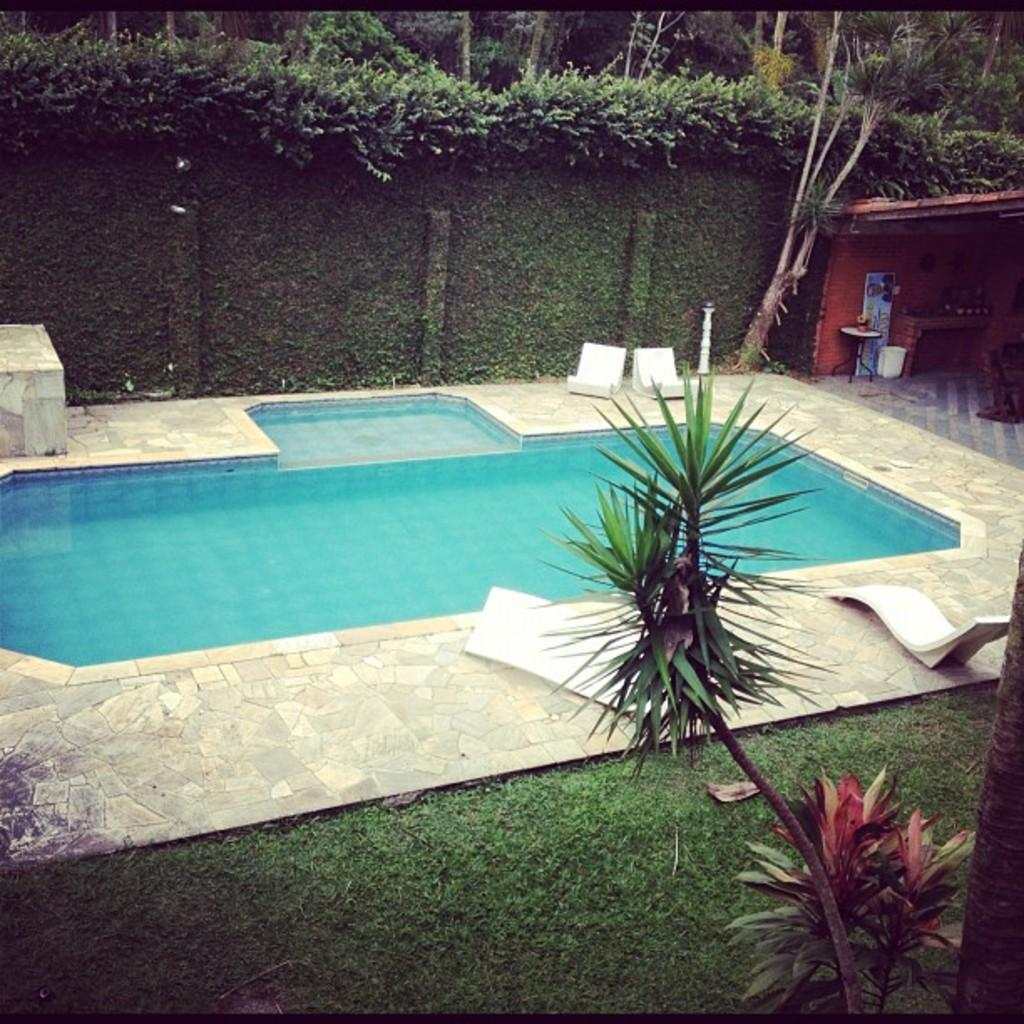What type of plants can be seen in the image? There are plants in the image. What type of ground cover is present in the image? There is grass in the image. What body of water is visible in the image? There is a swimming pool in the image. What type of seating is available in the image? There are chairs in the image. What type of structure is present in the image? There is a shed in the image. What type of decorative item is present on a table in the image? There is a vase with flowers on a table in the image. What type of sign or notice is present in the image? There is a board in the image. What other objects can be seen in the image? There are various objects in the image. What type of natural scenery is visible in the background of the image? There are trees in the background of the image. What language is spoken by the plants in the image? Plants do not speak any language, so this question cannot be answered. How much growth has the loss experienced in the image? There is no mention of loss in the image, so this question cannot be answered. 